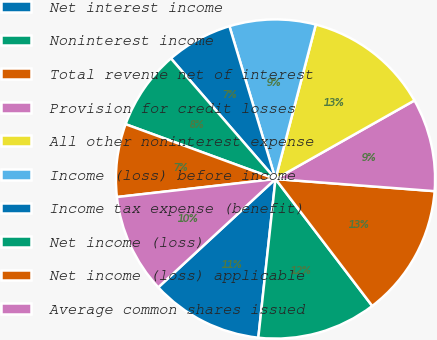Convert chart to OTSL. <chart><loc_0><loc_0><loc_500><loc_500><pie_chart><fcel>Net interest income<fcel>Noninterest income<fcel>Total revenue net of interest<fcel>Provision for credit losses<fcel>All other noninterest expense<fcel>Income (loss) before income<fcel>Income tax expense (benefit)<fcel>Net income (loss)<fcel>Net income (loss) applicable<fcel>Average common shares issued<nl><fcel>11.41%<fcel>12.08%<fcel>13.42%<fcel>9.4%<fcel>12.75%<fcel>8.72%<fcel>6.71%<fcel>8.05%<fcel>7.38%<fcel>10.07%<nl></chart> 